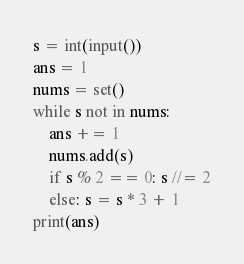Convert code to text. <code><loc_0><loc_0><loc_500><loc_500><_Python_>s = int(input())
ans = 1
nums = set()
while s not in nums:
    ans += 1
    nums.add(s)
    if s % 2 == 0: s //= 2
    else: s = s * 3 + 1
print(ans)
</code> 